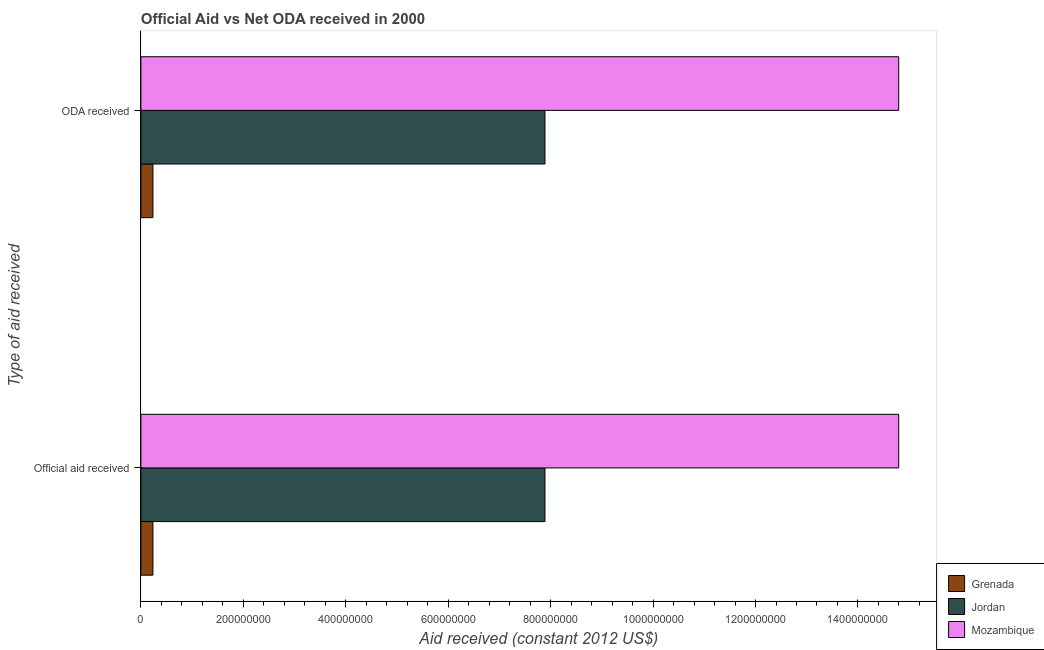How many different coloured bars are there?
Ensure brevity in your answer.  3. Are the number of bars per tick equal to the number of legend labels?
Your answer should be very brief. Yes. Are the number of bars on each tick of the Y-axis equal?
Ensure brevity in your answer.  Yes. How many bars are there on the 1st tick from the top?
Give a very brief answer. 3. How many bars are there on the 1st tick from the bottom?
Provide a succinct answer. 3. What is the label of the 2nd group of bars from the top?
Your answer should be very brief. Official aid received. What is the official aid received in Grenada?
Provide a succinct answer. 2.35e+07. Across all countries, what is the maximum official aid received?
Ensure brevity in your answer.  1.48e+09. Across all countries, what is the minimum oda received?
Your answer should be very brief. 2.35e+07. In which country was the official aid received maximum?
Keep it short and to the point. Mozambique. In which country was the official aid received minimum?
Your answer should be compact. Grenada. What is the total official aid received in the graph?
Your answer should be very brief. 2.29e+09. What is the difference between the official aid received in Grenada and that in Mozambique?
Offer a terse response. -1.46e+09. What is the difference between the official aid received in Grenada and the oda received in Jordan?
Provide a succinct answer. -7.65e+08. What is the average oda received per country?
Offer a very short reply. 7.64e+08. What is the ratio of the oda received in Mozambique to that in Grenada?
Make the answer very short. 63.01. Is the official aid received in Mozambique less than that in Grenada?
Your response must be concise. No. In how many countries, is the official aid received greater than the average official aid received taken over all countries?
Ensure brevity in your answer.  2. What does the 3rd bar from the top in ODA received represents?
Provide a succinct answer. Grenada. What does the 2nd bar from the bottom in Official aid received represents?
Give a very brief answer. Jordan. How many countries are there in the graph?
Offer a very short reply. 3. What is the difference between two consecutive major ticks on the X-axis?
Ensure brevity in your answer.  2.00e+08. Does the graph contain any zero values?
Give a very brief answer. No. Where does the legend appear in the graph?
Your response must be concise. Bottom right. What is the title of the graph?
Offer a terse response. Official Aid vs Net ODA received in 2000 . What is the label or title of the X-axis?
Offer a terse response. Aid received (constant 2012 US$). What is the label or title of the Y-axis?
Ensure brevity in your answer.  Type of aid received. What is the Aid received (constant 2012 US$) of Grenada in Official aid received?
Offer a very short reply. 2.35e+07. What is the Aid received (constant 2012 US$) in Jordan in Official aid received?
Your answer should be compact. 7.89e+08. What is the Aid received (constant 2012 US$) of Mozambique in Official aid received?
Your answer should be compact. 1.48e+09. What is the Aid received (constant 2012 US$) in Grenada in ODA received?
Provide a short and direct response. 2.35e+07. What is the Aid received (constant 2012 US$) of Jordan in ODA received?
Ensure brevity in your answer.  7.89e+08. What is the Aid received (constant 2012 US$) of Mozambique in ODA received?
Make the answer very short. 1.48e+09. Across all Type of aid received, what is the maximum Aid received (constant 2012 US$) in Grenada?
Your response must be concise. 2.35e+07. Across all Type of aid received, what is the maximum Aid received (constant 2012 US$) in Jordan?
Keep it short and to the point. 7.89e+08. Across all Type of aid received, what is the maximum Aid received (constant 2012 US$) of Mozambique?
Give a very brief answer. 1.48e+09. Across all Type of aid received, what is the minimum Aid received (constant 2012 US$) of Grenada?
Ensure brevity in your answer.  2.35e+07. Across all Type of aid received, what is the minimum Aid received (constant 2012 US$) of Jordan?
Ensure brevity in your answer.  7.89e+08. Across all Type of aid received, what is the minimum Aid received (constant 2012 US$) of Mozambique?
Ensure brevity in your answer.  1.48e+09. What is the total Aid received (constant 2012 US$) of Grenada in the graph?
Provide a succinct answer. 4.70e+07. What is the total Aid received (constant 2012 US$) of Jordan in the graph?
Provide a succinct answer. 1.58e+09. What is the total Aid received (constant 2012 US$) of Mozambique in the graph?
Offer a terse response. 2.96e+09. What is the difference between the Aid received (constant 2012 US$) in Grenada in Official aid received and that in ODA received?
Make the answer very short. 0. What is the difference between the Aid received (constant 2012 US$) of Mozambique in Official aid received and that in ODA received?
Make the answer very short. 0. What is the difference between the Aid received (constant 2012 US$) of Grenada in Official aid received and the Aid received (constant 2012 US$) of Jordan in ODA received?
Provide a short and direct response. -7.65e+08. What is the difference between the Aid received (constant 2012 US$) of Grenada in Official aid received and the Aid received (constant 2012 US$) of Mozambique in ODA received?
Your answer should be compact. -1.46e+09. What is the difference between the Aid received (constant 2012 US$) of Jordan in Official aid received and the Aid received (constant 2012 US$) of Mozambique in ODA received?
Provide a short and direct response. -6.91e+08. What is the average Aid received (constant 2012 US$) of Grenada per Type of aid received?
Keep it short and to the point. 2.35e+07. What is the average Aid received (constant 2012 US$) in Jordan per Type of aid received?
Keep it short and to the point. 7.89e+08. What is the average Aid received (constant 2012 US$) of Mozambique per Type of aid received?
Your response must be concise. 1.48e+09. What is the difference between the Aid received (constant 2012 US$) of Grenada and Aid received (constant 2012 US$) of Jordan in Official aid received?
Offer a terse response. -7.65e+08. What is the difference between the Aid received (constant 2012 US$) of Grenada and Aid received (constant 2012 US$) of Mozambique in Official aid received?
Your answer should be compact. -1.46e+09. What is the difference between the Aid received (constant 2012 US$) in Jordan and Aid received (constant 2012 US$) in Mozambique in Official aid received?
Your answer should be compact. -6.91e+08. What is the difference between the Aid received (constant 2012 US$) in Grenada and Aid received (constant 2012 US$) in Jordan in ODA received?
Provide a short and direct response. -7.65e+08. What is the difference between the Aid received (constant 2012 US$) in Grenada and Aid received (constant 2012 US$) in Mozambique in ODA received?
Offer a terse response. -1.46e+09. What is the difference between the Aid received (constant 2012 US$) in Jordan and Aid received (constant 2012 US$) in Mozambique in ODA received?
Give a very brief answer. -6.91e+08. What is the difference between the highest and the second highest Aid received (constant 2012 US$) in Jordan?
Give a very brief answer. 0. What is the difference between the highest and the lowest Aid received (constant 2012 US$) of Grenada?
Provide a short and direct response. 0. 